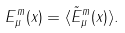Convert formula to latex. <formula><loc_0><loc_0><loc_500><loc_500>E ^ { m } _ { \mu } ( x ) = \langle \tilde { E } ^ { m } _ { \mu } ( x ) \rangle .</formula> 